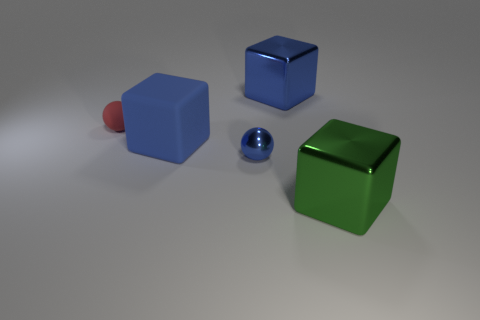Is there a small cyan cube?
Provide a short and direct response. No. Does the big blue thing behind the small red rubber sphere have the same material as the big blue object in front of the small red matte sphere?
Make the answer very short. No. There is a shiny object behind the blue block to the left of the large metallic block behind the large green block; how big is it?
Your answer should be very brief. Large. How many big blue cubes are the same material as the blue sphere?
Provide a succinct answer. 1. Is the number of big blue matte objects less than the number of tiny gray matte cubes?
Offer a terse response. No. What is the size of the blue metallic object that is the same shape as the big green metal thing?
Your answer should be very brief. Large. Do the blue thing behind the red ball and the green object have the same material?
Ensure brevity in your answer.  Yes. Does the tiny red object have the same shape as the large green shiny object?
Your answer should be compact. No. How many things are either things that are behind the green shiny block or big blue blocks?
Your response must be concise. 4. There is a blue cube that is the same material as the small blue thing; what is its size?
Keep it short and to the point. Large. 